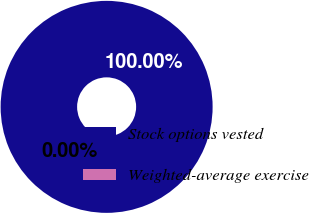Convert chart. <chart><loc_0><loc_0><loc_500><loc_500><pie_chart><fcel>Stock options vested<fcel>Weighted-average exercise<nl><fcel>100.0%<fcel>0.0%<nl></chart> 